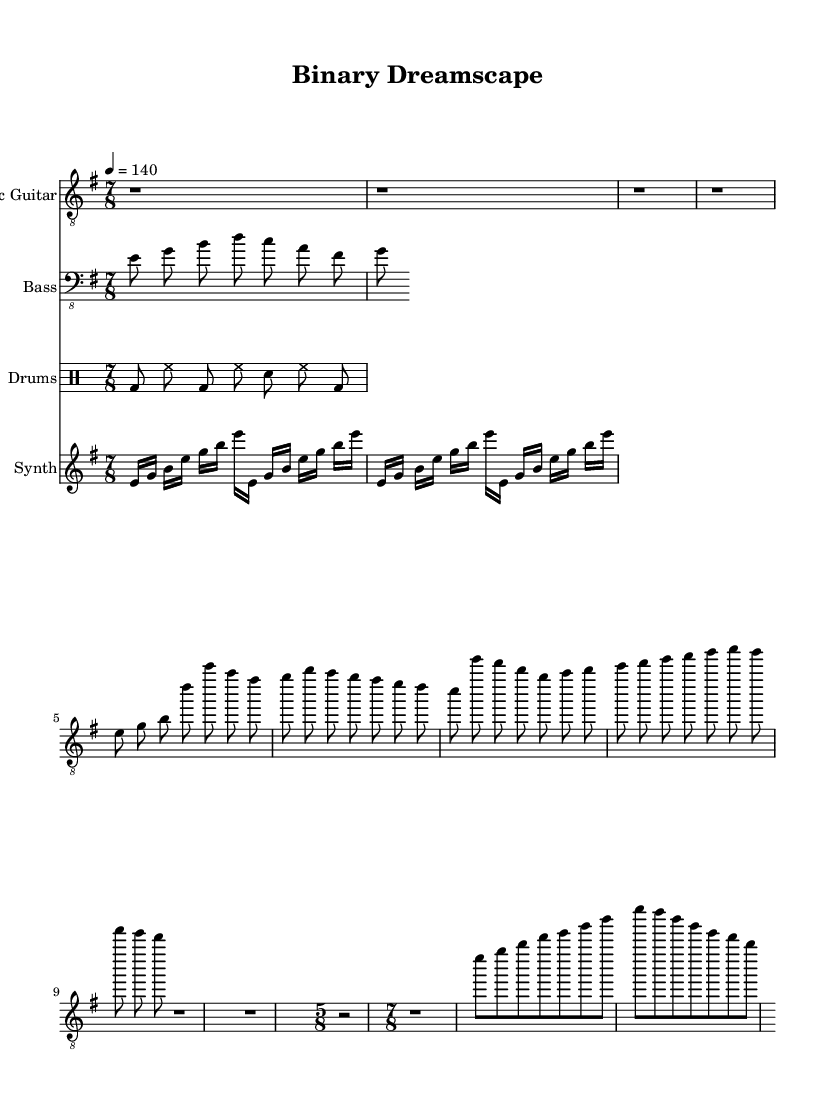What is the key signature of this music? The key signature is E minor, which has one sharp (F#) and corresponds to the natural minor scale starting on E.
Answer: E minor What is the time signature of the main sections? The main sections are written in 7/8 time, which indicates that each measure has seven eighth-note beats. This is evident from the time signature displayed in the global declaration.
Answer: 7/8 What is the tempo marking of this composition? The tempo marking is 140 beats per minute, denoted by "4 = 140" which refers to the quarter note equating to 140 bpm.
Answer: 140 How many measures are in the Intro section? The Intro consists of four measures, each being a rest for the entire duration of 7/8 time, resulting in four r1*7/8 notations shown.
Answer: 4 What is the rhythmic pattern of the drum part? The drum part includes a recurring pattern of bass drum, hi-hat, and snare, specifically consisting of bass and hi-hat notes in the first half and bass and snare in the second. The exact order allows us to identify its rhythmic structure.
Answer: Bass and hi-hat What does the guitar solo utilize in terms of note choices? The guitar solo uses notes from the E minor scale, incorporating pitches such as E, G, B, and D, which are all within the harmonic context of E minor, demonstrating a focus on the scale throughout the solo part.
Answer: E minor scale 